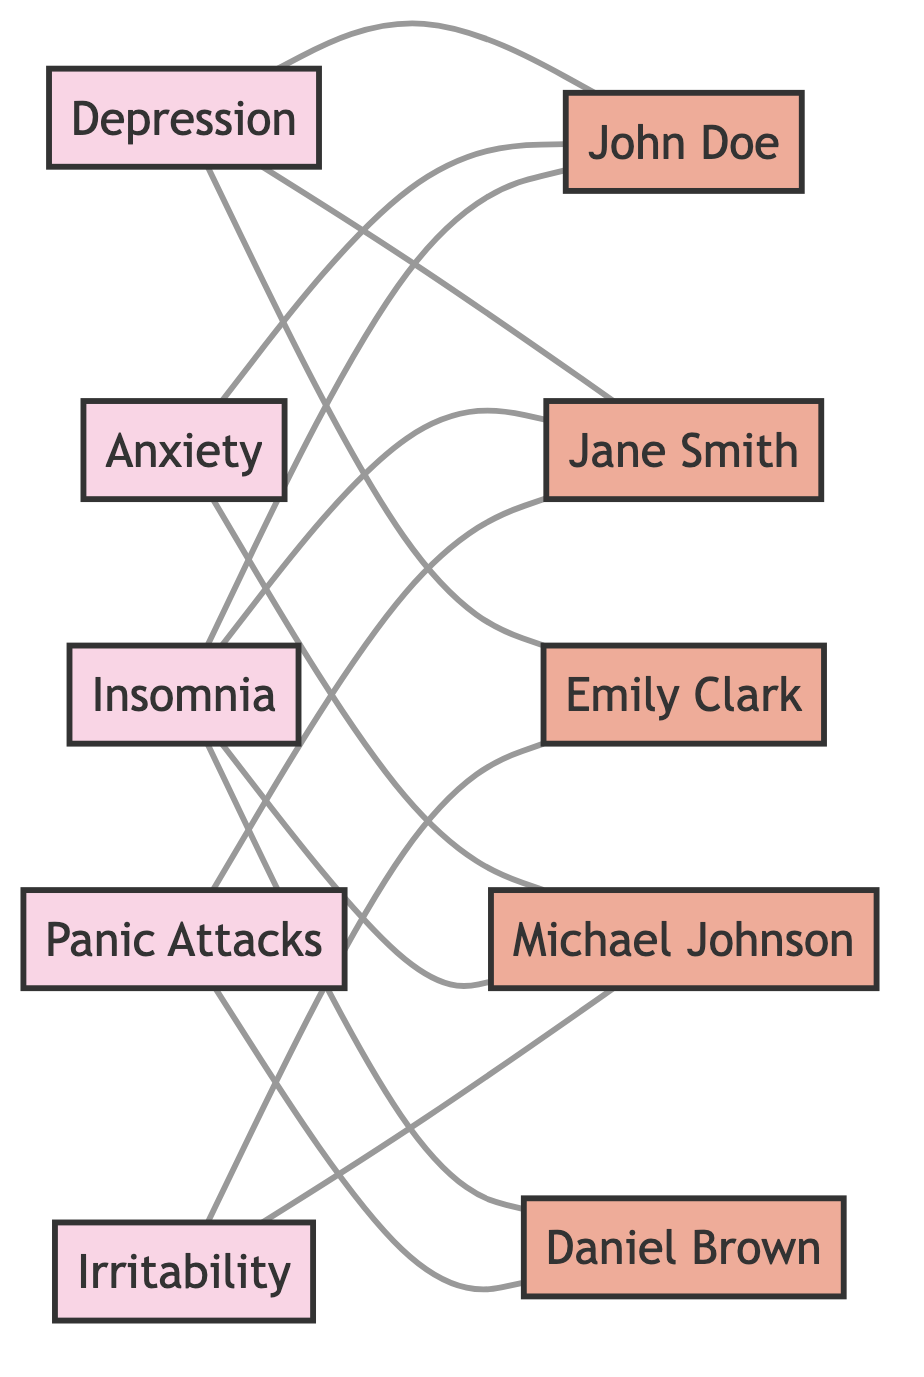What are the symptoms associated with John Doe? John Doe is linked to three symptoms: Depression, Anxiety, and Insomnia. This can be determined by tracing the nodes and edges connected to John Doe in the diagram.
Answer: Depression, Anxiety, Insomnia How many symptoms are represented in the diagram? The diagram shows five symptoms: Depression, Anxiety, Insomnia, Panic Attacks, and Irritability. This is counted by identifying the unique symptom nodes in the graph.
Answer: Five Which patient shares symptoms with the most other patients? By evaluating the connections of each patient to the symptom nodes, Jane Smith shares symptoms with three other patients (Depression with John Doe and Emily Clark; Insomnia with John Doe; Panic Attacks with Daniel Brown). Therefore, she has the most connections.
Answer: Jane Smith What symptom is linked to the highest number of patients? Insomnia is connected to four patients: John Doe, Jane Smith, Michael Johnson, and Daniel Brown. This is identified by counting the patient nodes connected to Insomnia in the graph.
Answer: Insomnia Which two patients experience the same symptoms? John Doe and Jane Smith both experience Depression and Insomnia. This is determined by comparing the symptoms associated with each patient in the diagram.
Answer: John Doe, Jane Smith 